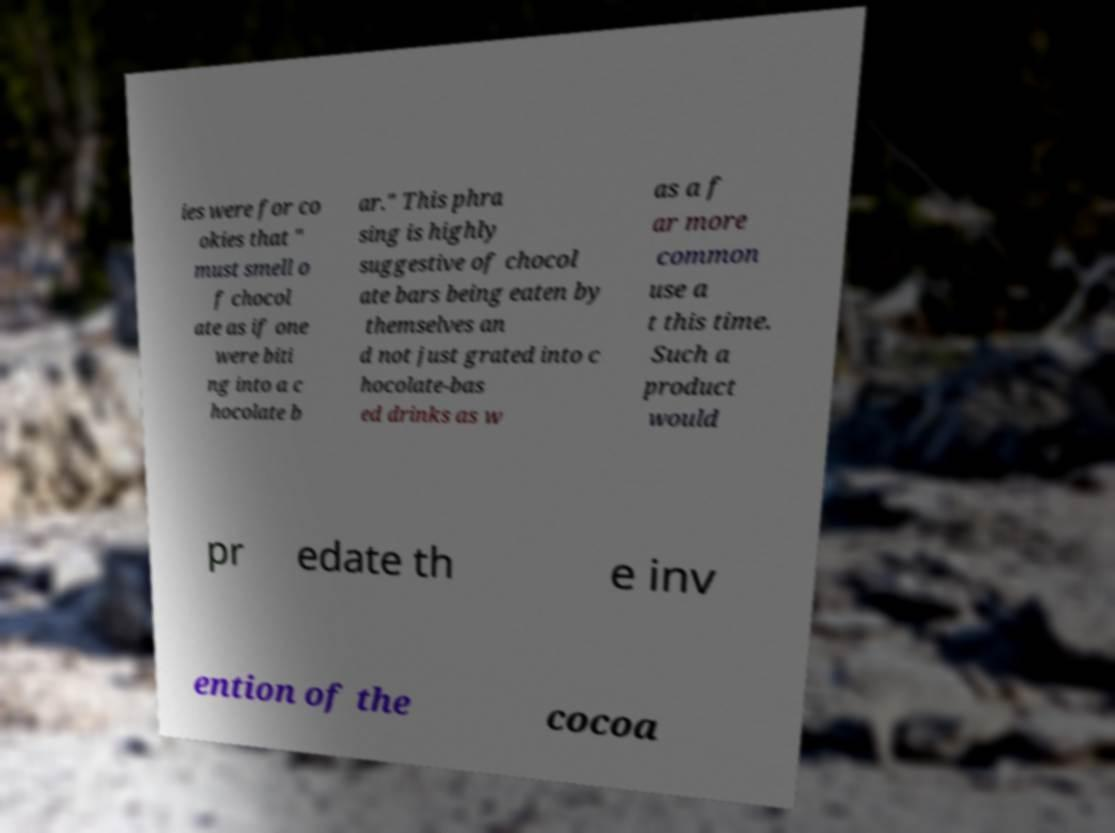For documentation purposes, I need the text within this image transcribed. Could you provide that? ies were for co okies that " must smell o f chocol ate as if one were biti ng into a c hocolate b ar." This phra sing is highly suggestive of chocol ate bars being eaten by themselves an d not just grated into c hocolate-bas ed drinks as w as a f ar more common use a t this time. Such a product would pr edate th e inv ention of the cocoa 